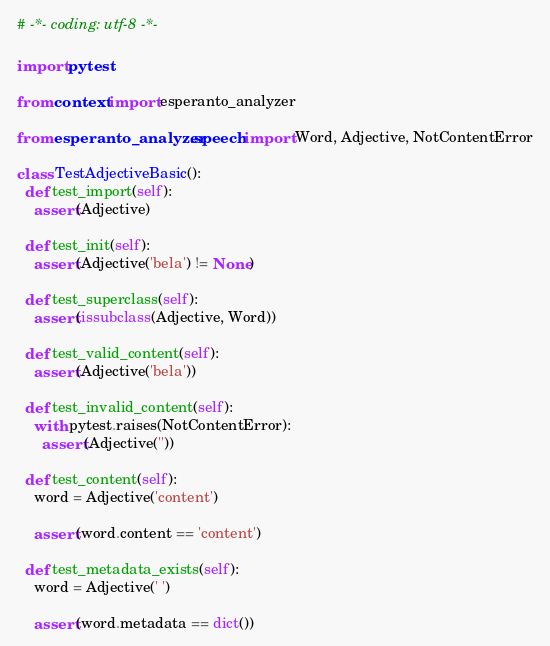Convert code to text. <code><loc_0><loc_0><loc_500><loc_500><_Python_># -*- coding: utf-8 -*-

import pytest

from context import esperanto_analyzer

from esperanto_analyzer.speech import Word, Adjective, NotContentError

class TestAdjectiveBasic():
  def test_import(self):
    assert(Adjective)

  def test_init(self):
    assert(Adjective('bela') != None)

  def test_superclass(self):
    assert(issubclass(Adjective, Word))

  def test_valid_content(self):
    assert(Adjective('bela'))

  def test_invalid_content(self):
    with pytest.raises(NotContentError):
      assert(Adjective(''))

  def test_content(self):
    word = Adjective('content')

    assert(word.content == 'content')

  def test_metadata_exists(self):
    word = Adjective(' ')

    assert(word.metadata == dict())
</code> 